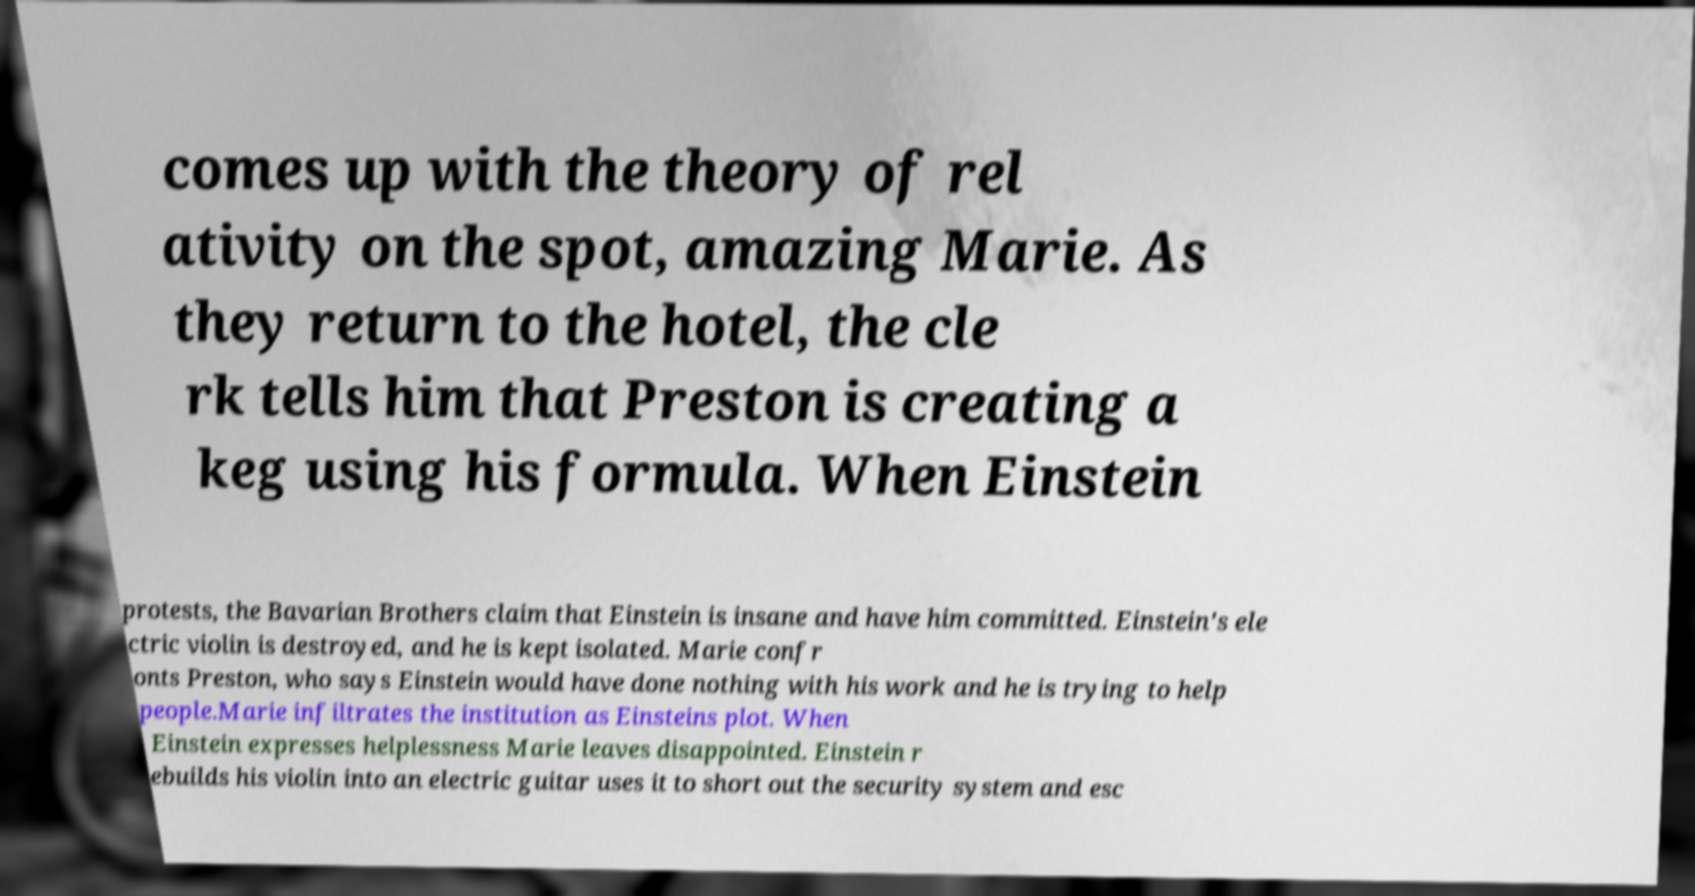Please read and relay the text visible in this image. What does it say? comes up with the theory of rel ativity on the spot, amazing Marie. As they return to the hotel, the cle rk tells him that Preston is creating a keg using his formula. When Einstein protests, the Bavarian Brothers claim that Einstein is insane and have him committed. Einstein's ele ctric violin is destroyed, and he is kept isolated. Marie confr onts Preston, who says Einstein would have done nothing with his work and he is trying to help people.Marie infiltrates the institution as Einsteins plot. When Einstein expresses helplessness Marie leaves disappointed. Einstein r ebuilds his violin into an electric guitar uses it to short out the security system and esc 